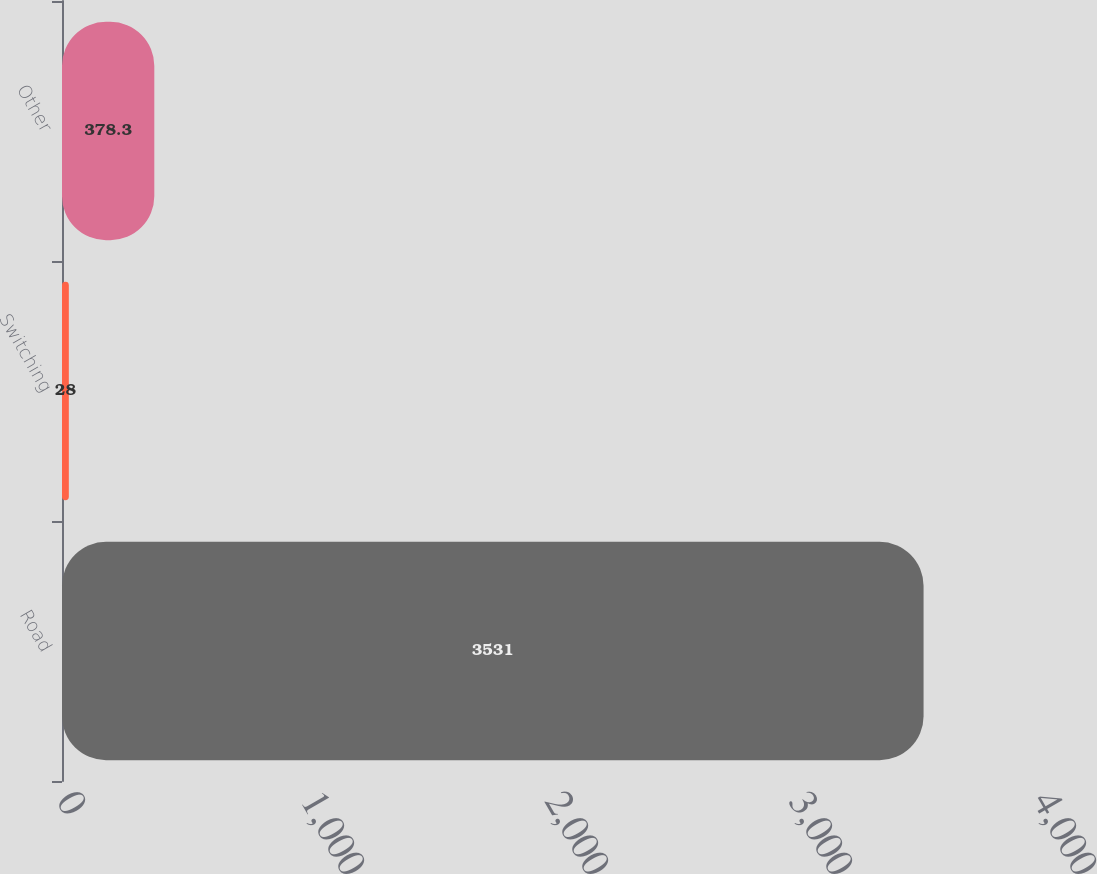Convert chart to OTSL. <chart><loc_0><loc_0><loc_500><loc_500><bar_chart><fcel>Road<fcel>Switching<fcel>Other<nl><fcel>3531<fcel>28<fcel>378.3<nl></chart> 